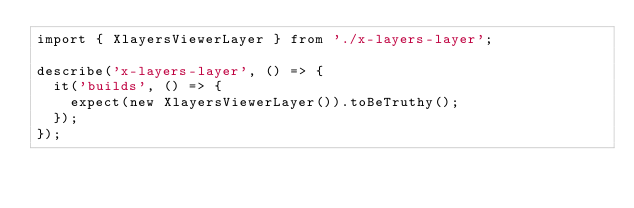<code> <loc_0><loc_0><loc_500><loc_500><_TypeScript_>import { XlayersViewerLayer } from './x-layers-layer';

describe('x-layers-layer', () => {
  it('builds', () => {
    expect(new XlayersViewerLayer()).toBeTruthy();
  });
});
</code> 